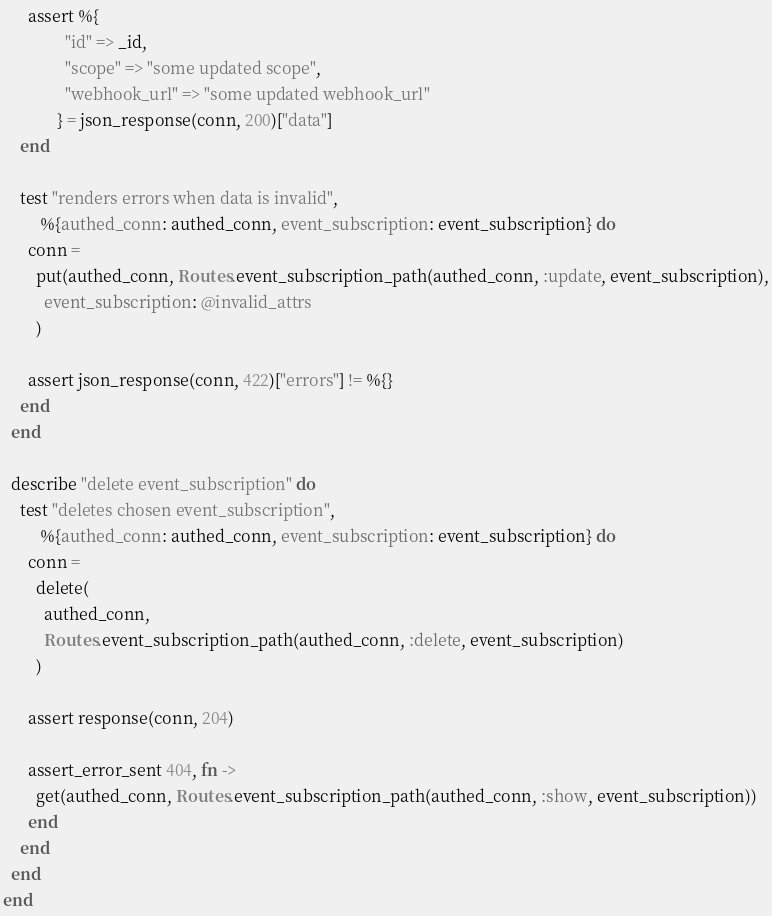Convert code to text. <code><loc_0><loc_0><loc_500><loc_500><_Elixir_>      assert %{
               "id" => _id,
               "scope" => "some updated scope",
               "webhook_url" => "some updated webhook_url"
             } = json_response(conn, 200)["data"]
    end

    test "renders errors when data is invalid",
         %{authed_conn: authed_conn, event_subscription: event_subscription} do
      conn =
        put(authed_conn, Routes.event_subscription_path(authed_conn, :update, event_subscription),
          event_subscription: @invalid_attrs
        )

      assert json_response(conn, 422)["errors"] != %{}
    end
  end

  describe "delete event_subscription" do
    test "deletes chosen event_subscription",
         %{authed_conn: authed_conn, event_subscription: event_subscription} do
      conn =
        delete(
          authed_conn,
          Routes.event_subscription_path(authed_conn, :delete, event_subscription)
        )

      assert response(conn, 204)

      assert_error_sent 404, fn ->
        get(authed_conn, Routes.event_subscription_path(authed_conn, :show, event_subscription))
      end
    end
  end
end
</code> 